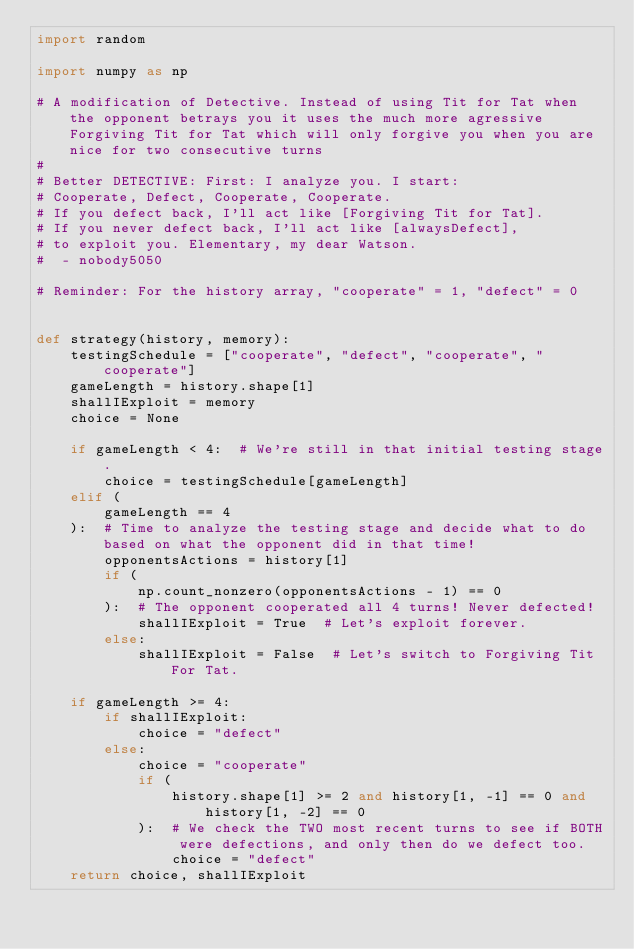Convert code to text. <code><loc_0><loc_0><loc_500><loc_500><_Python_>import random

import numpy as np

# A modification of Detective. Instead of using Tit for Tat when the opponent betrays you it uses the much more agressive Forgiving Tit for Tat which will only forgive you when you are nice for two consecutive turns
#
# Better DETECTIVE: First: I analyze you. I start:
# Cooperate, Defect, Cooperate, Cooperate.
# If you defect back, I'll act like [Forgiving Tit for Tat].
# If you never defect back, I'll act like [alwaysDefect],
# to exploit you. Elementary, my dear Watson.
#  - nobody5050

# Reminder: For the history array, "cooperate" = 1, "defect" = 0


def strategy(history, memory):
    testingSchedule = ["cooperate", "defect", "cooperate", "cooperate"]
    gameLength = history.shape[1]
    shallIExploit = memory
    choice = None

    if gameLength < 4:  # We're still in that initial testing stage.
        choice = testingSchedule[gameLength]
    elif (
        gameLength == 4
    ):  # Time to analyze the testing stage and decide what to do based on what the opponent did in that time!
        opponentsActions = history[1]
        if (
            np.count_nonzero(opponentsActions - 1) == 0
        ):  # The opponent cooperated all 4 turns! Never defected!
            shallIExploit = True  # Let's exploit forever.
        else:
            shallIExploit = False  # Let's switch to Forgiving Tit For Tat.

    if gameLength >= 4:
        if shallIExploit:
            choice = "defect"
        else:
            choice = "cooperate"
            if (
                history.shape[1] >= 2 and history[1, -1] == 0 and history[1, -2] == 0
            ):  # We check the TWO most recent turns to see if BOTH were defections, and only then do we defect too.
                choice = "defect"
    return choice, shallIExploit
</code> 